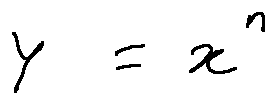Convert formula to latex. <formula><loc_0><loc_0><loc_500><loc_500>y = x ^ { n }</formula> 